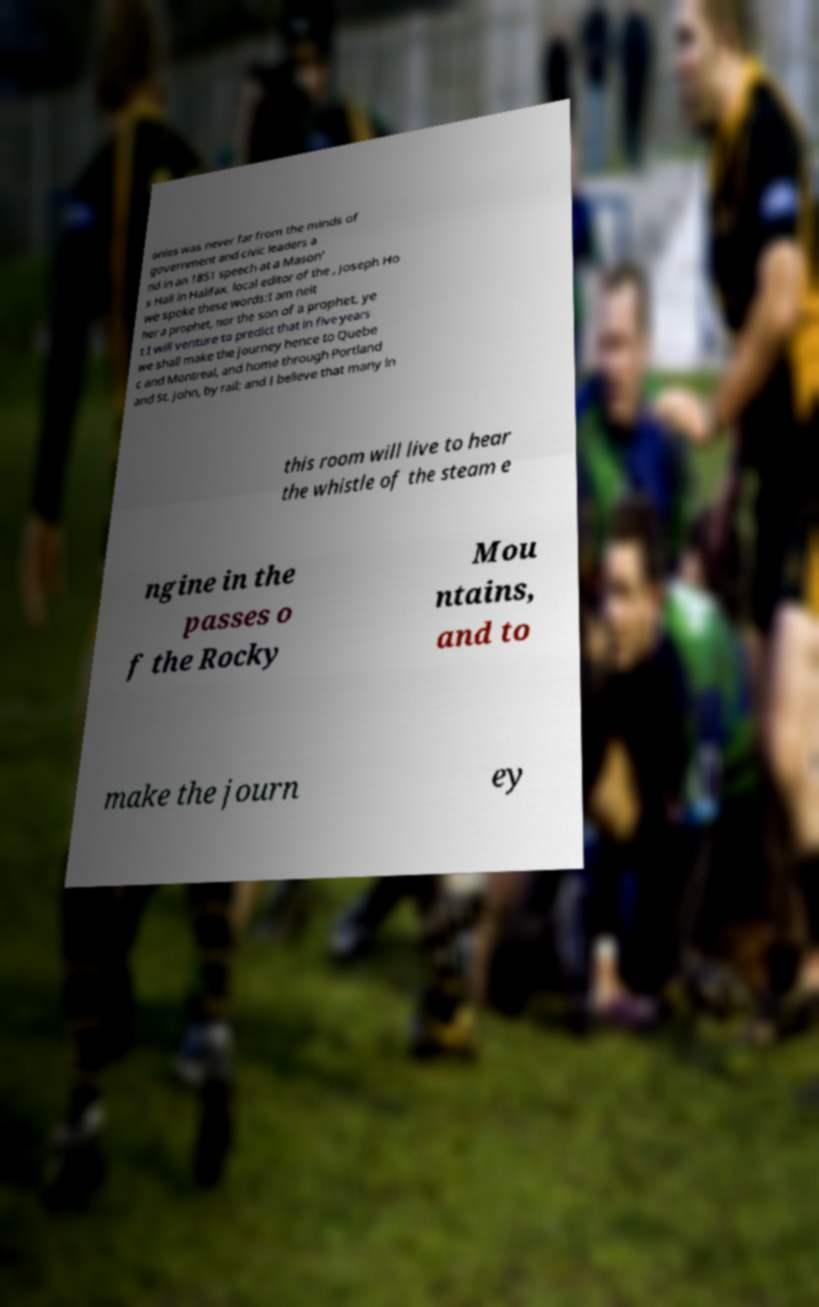Can you read and provide the text displayed in the image?This photo seems to have some interesting text. Can you extract and type it out for me? onies was never far from the minds of government and civic leaders a nd in an 1851 speech at a Mason' s Hall in Halifax, local editor of the , Joseph Ho we spoke these words:I am neit her a prophet, nor the son of a prophet, ye t I will venture to predict that in five years we shall make the journey hence to Quebe c and Montreal, and home through Portland and St. John, by rail; and I believe that many in this room will live to hear the whistle of the steam e ngine in the passes o f the Rocky Mou ntains, and to make the journ ey 